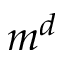<formula> <loc_0><loc_0><loc_500><loc_500>m ^ { d }</formula> 